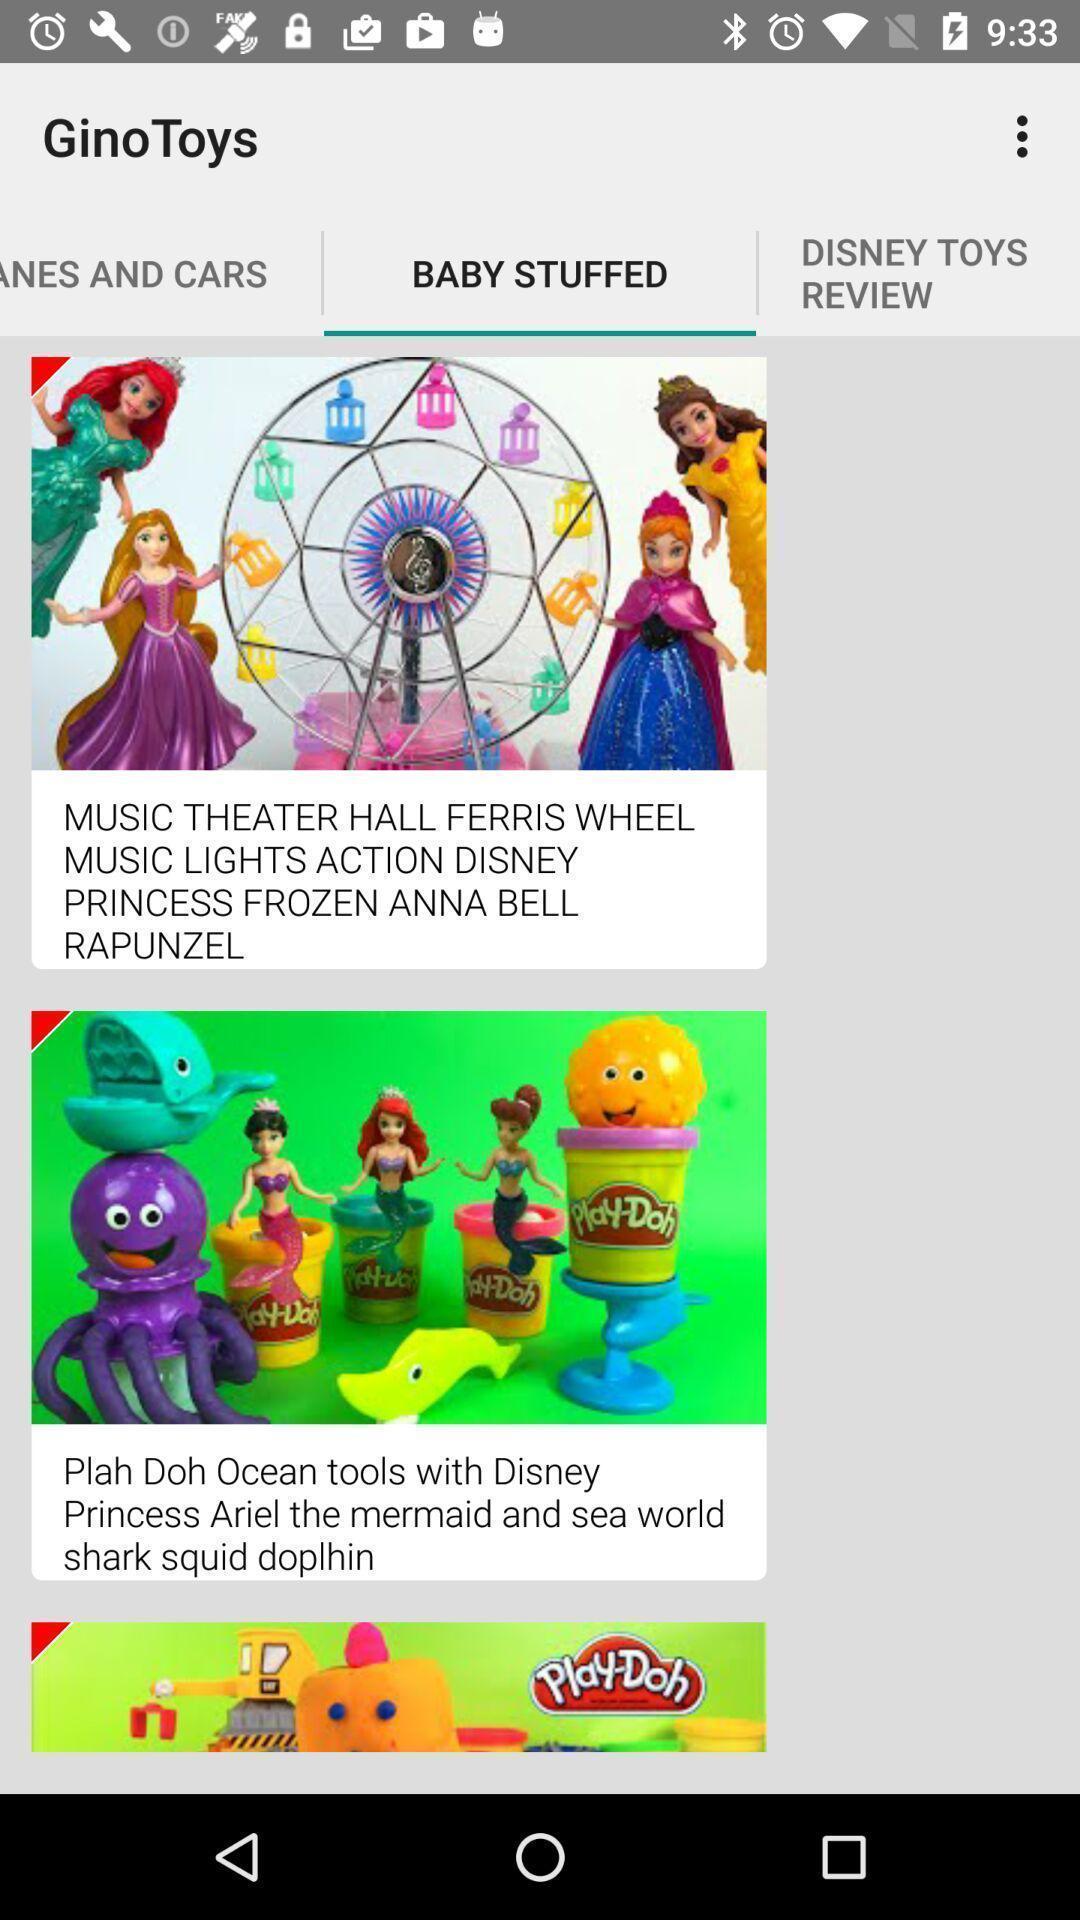Provide a textual representation of this image. Page displaying the various baby stuffed animations. 